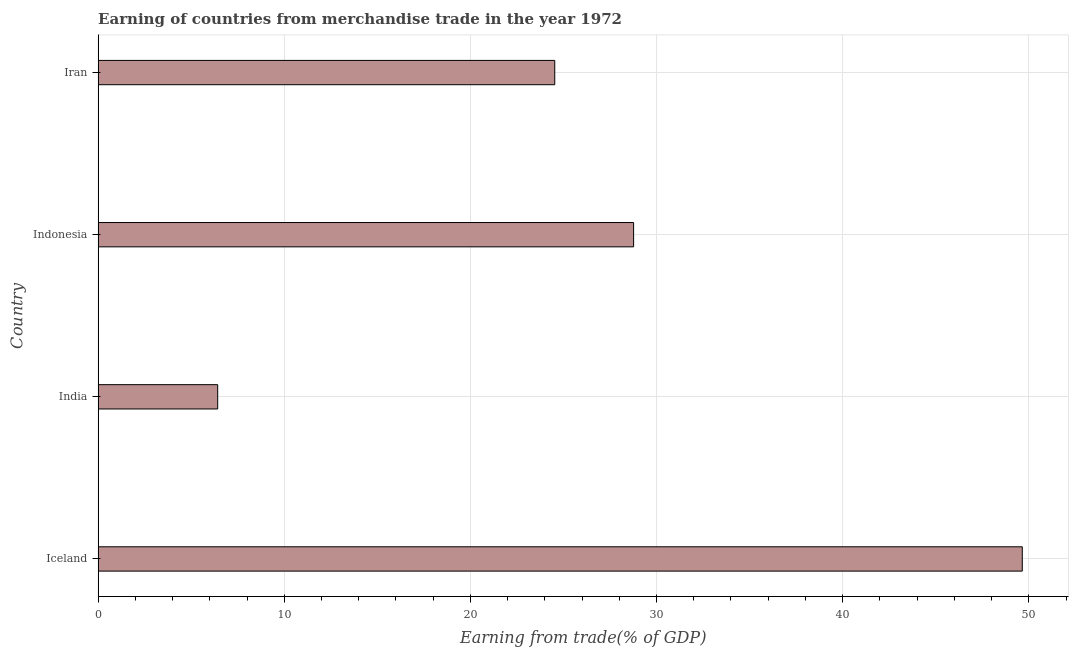What is the title of the graph?
Make the answer very short. Earning of countries from merchandise trade in the year 1972. What is the label or title of the X-axis?
Make the answer very short. Earning from trade(% of GDP). What is the label or title of the Y-axis?
Keep it short and to the point. Country. What is the earning from merchandise trade in India?
Your answer should be compact. 6.42. Across all countries, what is the maximum earning from merchandise trade?
Your answer should be very brief. 49.65. Across all countries, what is the minimum earning from merchandise trade?
Your response must be concise. 6.42. In which country was the earning from merchandise trade maximum?
Offer a terse response. Iceland. What is the sum of the earning from merchandise trade?
Your answer should be compact. 109.38. What is the difference between the earning from merchandise trade in Indonesia and Iran?
Your response must be concise. 4.24. What is the average earning from merchandise trade per country?
Ensure brevity in your answer.  27.34. What is the median earning from merchandise trade?
Ensure brevity in your answer.  26.65. In how many countries, is the earning from merchandise trade greater than 12 %?
Offer a terse response. 3. What is the ratio of the earning from merchandise trade in India to that in Indonesia?
Give a very brief answer. 0.22. Is the earning from merchandise trade in Iceland less than that in Iran?
Provide a short and direct response. No. What is the difference between the highest and the second highest earning from merchandise trade?
Offer a terse response. 20.88. Is the sum of the earning from merchandise trade in India and Indonesia greater than the maximum earning from merchandise trade across all countries?
Provide a succinct answer. No. What is the difference between the highest and the lowest earning from merchandise trade?
Provide a succinct answer. 43.23. In how many countries, is the earning from merchandise trade greater than the average earning from merchandise trade taken over all countries?
Ensure brevity in your answer.  2. How many bars are there?
Your answer should be compact. 4. What is the Earning from trade(% of GDP) in Iceland?
Your answer should be compact. 49.65. What is the Earning from trade(% of GDP) in India?
Provide a succinct answer. 6.42. What is the Earning from trade(% of GDP) in Indonesia?
Offer a terse response. 28.77. What is the Earning from trade(% of GDP) in Iran?
Give a very brief answer. 24.53. What is the difference between the Earning from trade(% of GDP) in Iceland and India?
Give a very brief answer. 43.23. What is the difference between the Earning from trade(% of GDP) in Iceland and Indonesia?
Give a very brief answer. 20.88. What is the difference between the Earning from trade(% of GDP) in Iceland and Iran?
Your response must be concise. 25.12. What is the difference between the Earning from trade(% of GDP) in India and Indonesia?
Your answer should be very brief. -22.35. What is the difference between the Earning from trade(% of GDP) in India and Iran?
Make the answer very short. -18.11. What is the difference between the Earning from trade(% of GDP) in Indonesia and Iran?
Ensure brevity in your answer.  4.24. What is the ratio of the Earning from trade(% of GDP) in Iceland to that in India?
Offer a very short reply. 7.73. What is the ratio of the Earning from trade(% of GDP) in Iceland to that in Indonesia?
Ensure brevity in your answer.  1.73. What is the ratio of the Earning from trade(% of GDP) in Iceland to that in Iran?
Offer a very short reply. 2.02. What is the ratio of the Earning from trade(% of GDP) in India to that in Indonesia?
Give a very brief answer. 0.22. What is the ratio of the Earning from trade(% of GDP) in India to that in Iran?
Provide a short and direct response. 0.26. What is the ratio of the Earning from trade(% of GDP) in Indonesia to that in Iran?
Provide a short and direct response. 1.17. 